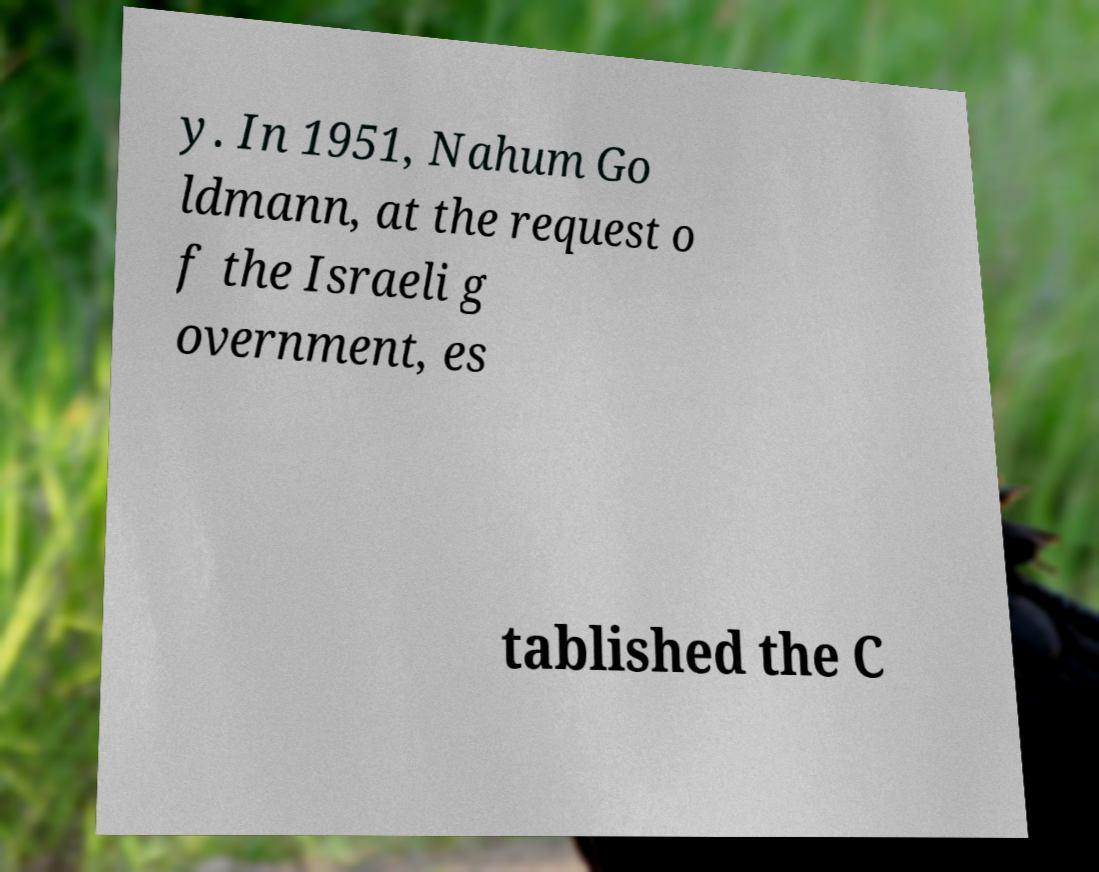Could you extract and type out the text from this image? y. In 1951, Nahum Go ldmann, at the request o f the Israeli g overnment, es tablished the C 